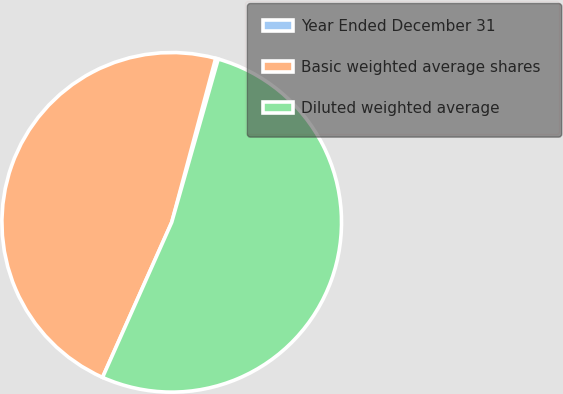<chart> <loc_0><loc_0><loc_500><loc_500><pie_chart><fcel>Year Ended December 31<fcel>Basic weighted average shares<fcel>Diluted weighted average<nl><fcel>0.25%<fcel>47.49%<fcel>52.26%<nl></chart> 